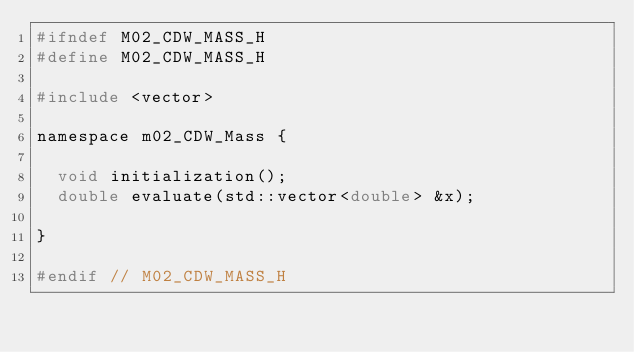Convert code to text. <code><loc_0><loc_0><loc_500><loc_500><_C_>#ifndef M02_CDW_MASS_H
#define M02_CDW_MASS_H

#include <vector>

namespace m02_CDW_Mass {

  void initialization();
  double evaluate(std::vector<double> &x);

}

#endif // M02_CDW_MASS_H
</code> 